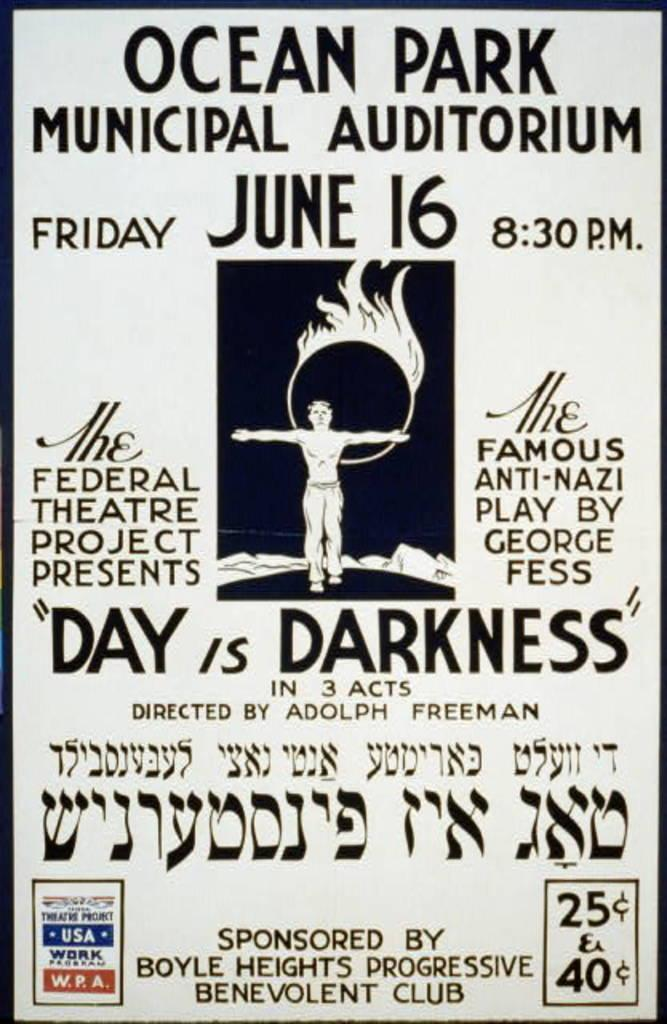Provide a one-sentence caption for the provided image. A black and white poster for Ocean Park Municipal Auditorium. 